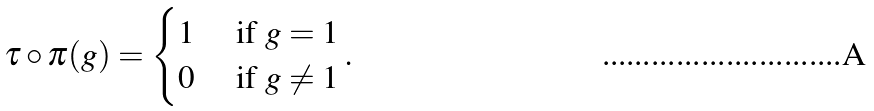<formula> <loc_0><loc_0><loc_500><loc_500>\tau \circ \pi ( g ) = \begin{cases} 1 & \text { if } g = 1 \\ 0 & \text { if } g \neq 1 \end{cases} .</formula> 